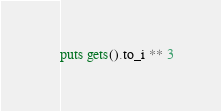Convert code to text. <code><loc_0><loc_0><loc_500><loc_500><_Ruby_>puts gets().to_i ** 3</code> 